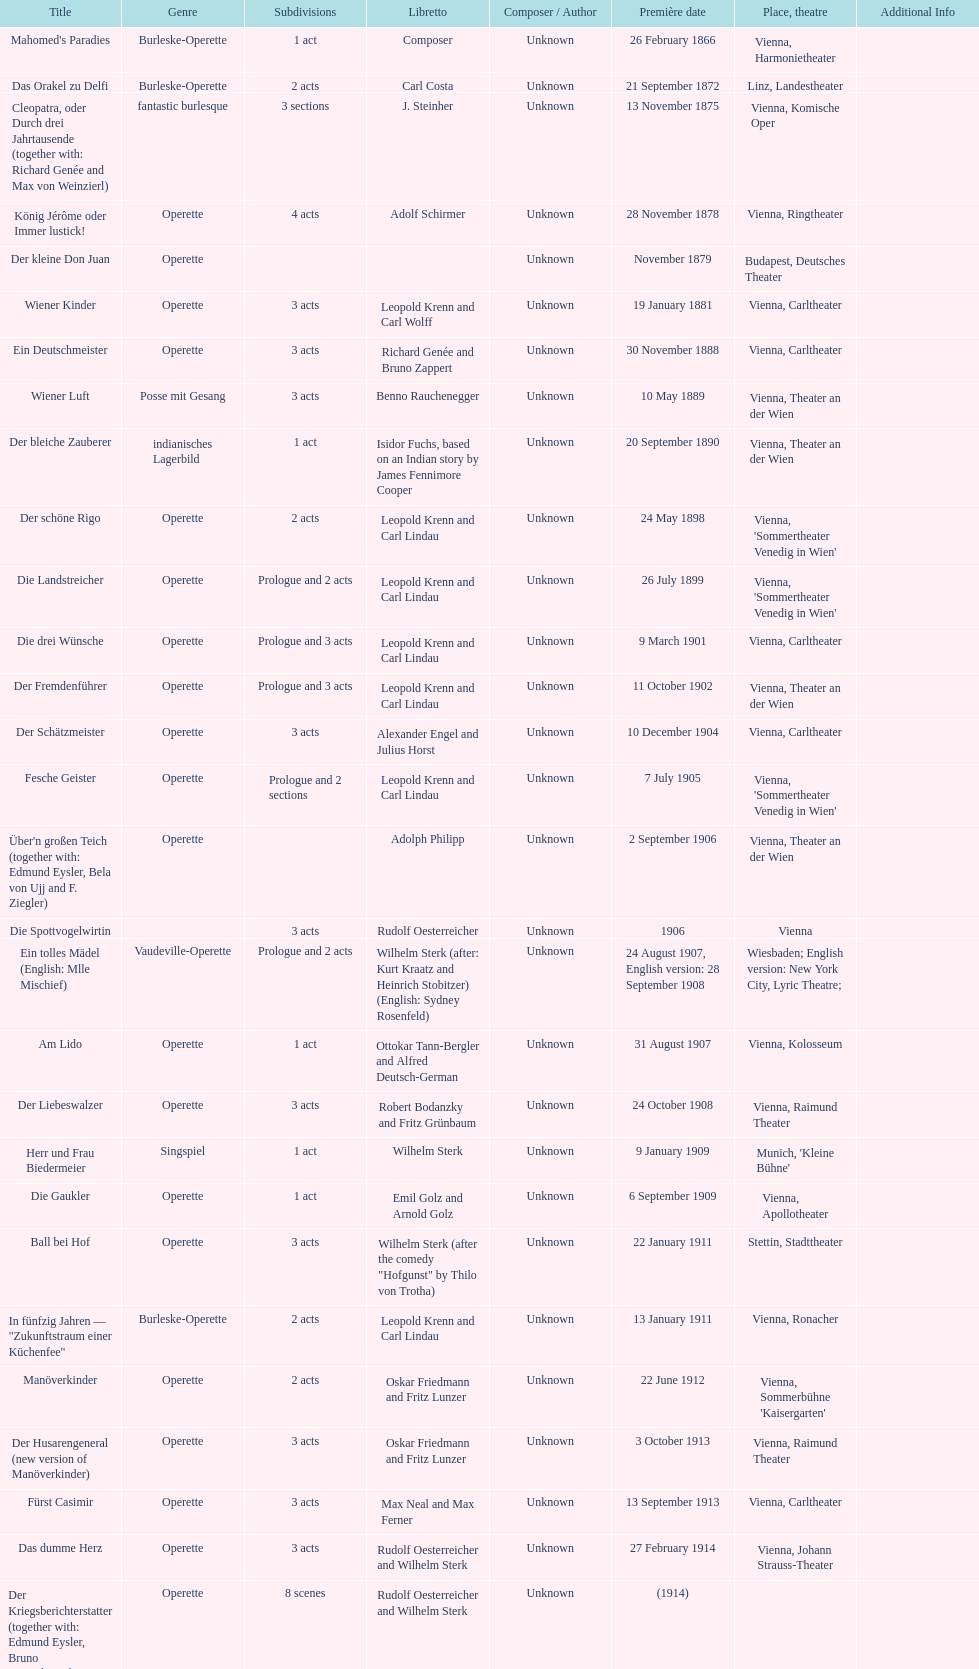In which city did the most operettas premiere? Vienna. 